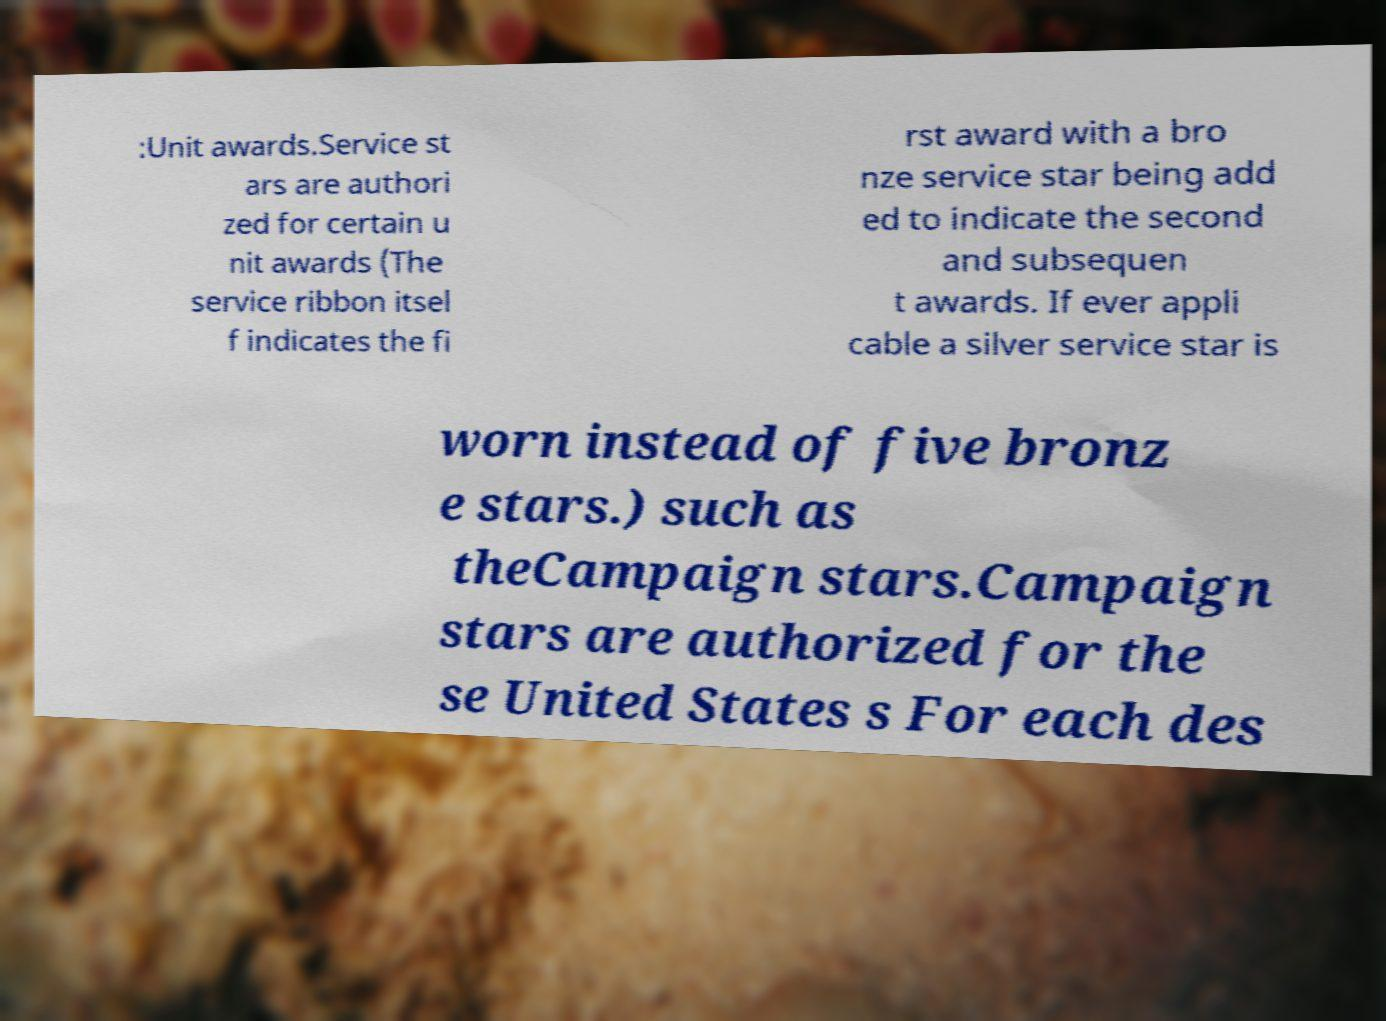For documentation purposes, I need the text within this image transcribed. Could you provide that? :Unit awards.Service st ars are authori zed for certain u nit awards (The service ribbon itsel f indicates the fi rst award with a bro nze service star being add ed to indicate the second and subsequen t awards. If ever appli cable a silver service star is worn instead of five bronz e stars.) such as theCampaign stars.Campaign stars are authorized for the se United States s For each des 